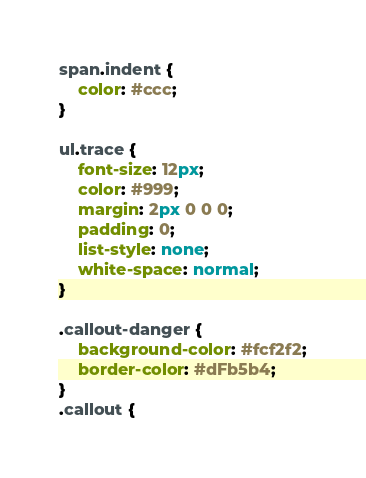Convert code to text. <code><loc_0><loc_0><loc_500><loc_500><_CSS_>span.indent {
	color: #ccc;
}

ul.trace {
	font-size: 12px;
	color: #999;
	margin: 2px 0 0 0;
	padding: 0;
	list-style: none;
	white-space: normal;
}

.callout-danger {
	background-color: #fcf2f2;
	border-color: #dFb5b4;
}
.callout {</code> 